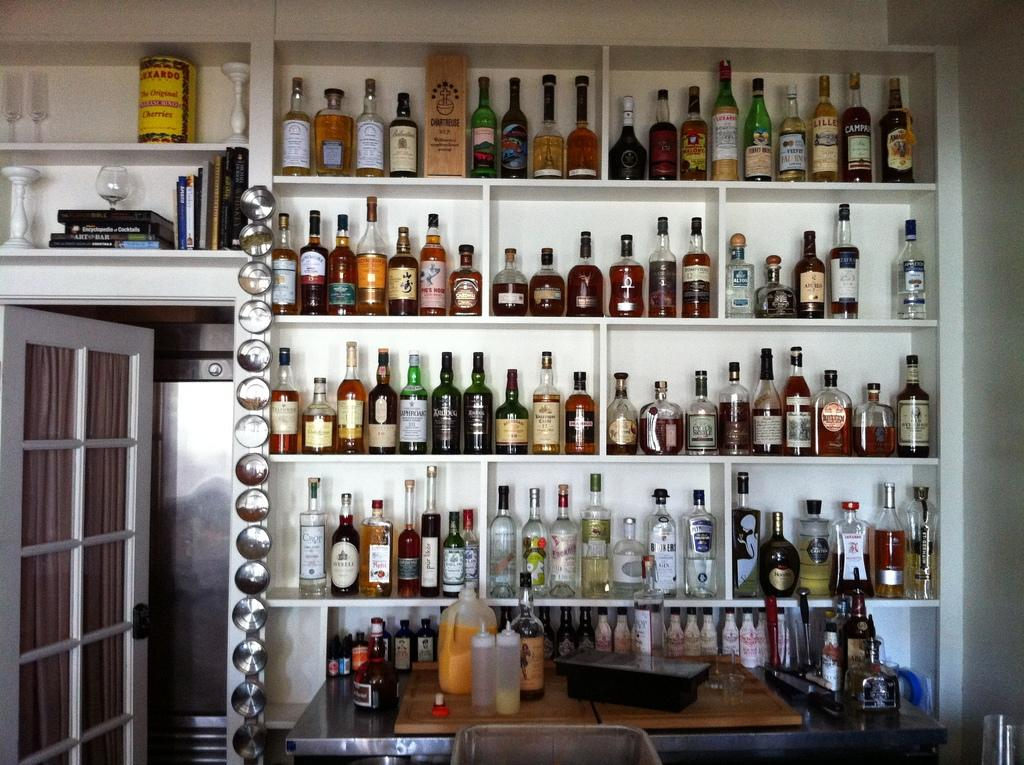What is stored in the racks in the image? There are bottles in racks in the image. Are there any bottles not in the racks? Yes, there are additional bottles in front of the racks. What is on the table in the image? There is a can on a table in the image. What type of furniture is present in the image? There is a bed in the image. What architectural feature is visible in the image? There is a door in the image. What type of object is made of glass in the image? There is a glass object in the image. What else is stored in a rack in the image? There are books in a rack in the image. What type of nerve is visible in the image? There is no nerve present in the image. What type of punishment is being administered in the image? There is no punishment being administered in the image. 